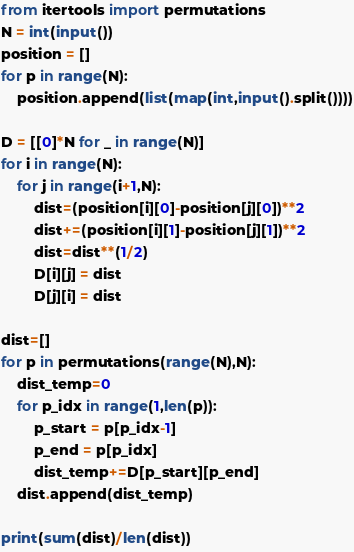<code> <loc_0><loc_0><loc_500><loc_500><_Python_>from itertools import permutations
N = int(input())
position = []
for p in range(N):
    position.append(list(map(int,input().split())))

D = [[0]*N for _ in range(N)]
for i in range(N):
    for j in range(i+1,N):
        dist=(position[i][0]-position[j][0])**2
        dist+=(position[i][1]-position[j][1])**2
        dist=dist**(1/2)
        D[i][j] = dist
        D[j][i] = dist

dist=[]
for p in permutations(range(N),N):
    dist_temp=0
    for p_idx in range(1,len(p)):
        p_start = p[p_idx-1]
        p_end = p[p_idx]
        dist_temp+=D[p_start][p_end]
    dist.append(dist_temp)
        
print(sum(dist)/len(dist))</code> 